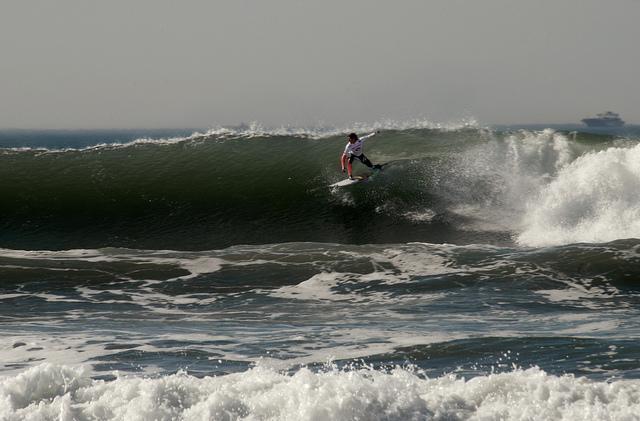How many people in the water?
Give a very brief answer. 1. 